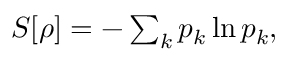<formula> <loc_0><loc_0><loc_500><loc_500>\begin{array} { r } { S [ \rho ] = - \sum _ { k } p _ { k } \ln { p _ { k } } , } \end{array}</formula> 